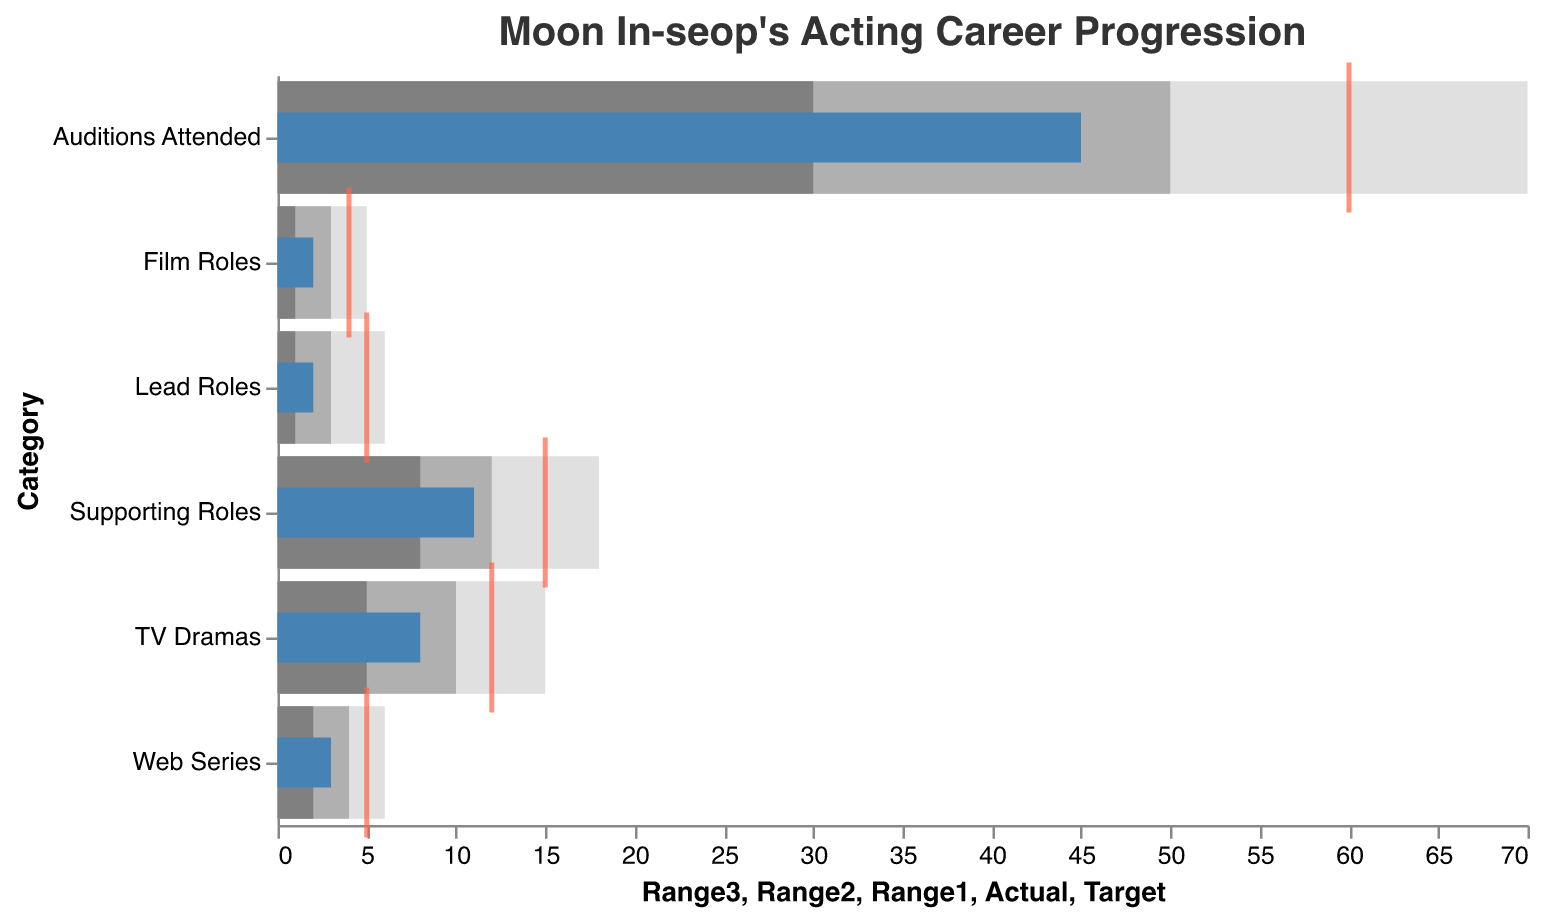What is the title of the figure? The title of the figure is placed at the top and its text is clearly shown.
Answer: Moon In-seop's Acting Career Progression How many lead roles has Moon In-seop secured? Looking at the "Actual" value in the "Lead Roles" category, it shows the number of roles actually secured.
Answer: 2 What is the target number of TV Drama roles for Moon In-seop? Referring to the "Target" value in the "TV Dramas" category.
Answer: 12 How many categories are displayed in the figure? Counting the number of unique categories along the vertical axis provides the answer.
Answer: 6 What is the difference in the actual number of web series roles and film roles secured by Moon In-seop? We need to subtract the "Actual" value of "Film Roles" from the "Actual" value of "Web Series." The values are 3 and 2 respectively.
Answer: 1 Which category exceeds its Range1 but stays below its Target? We observe that the "Actual" values greater than "Range1" but less than "Target."
Answer: TV Dramas What is the ratio of auditions attended to the number of TV Dramas Moon In-seop secured? The "Actual" values for "Auditions Attended" and "TV Dramas" are 45 and 8 respectively. Divide the number of auditions by the number of secured TV Dramas.
Answer: 5.625 How many more supporting roles has Moon In-seop secured compared to lead roles? Subtract the number of "Lead Roles" from "Supporting Roles." The values are 11 for Supporting Roles and 2 for Lead Roles.
Answer: 9 Which category has an "Actual" value that meets or exceeds its Range2? Checking the "Actual" values against the "Range2" values for each category, we find the relevant one.
Answer: TV Dramas How far below the target is the actual number of Film Roles compared to its target? We calculate the difference between the "Actual" and "Target" values for "Film Roles." The values are 2 and 4 respectively.
Answer: 2 